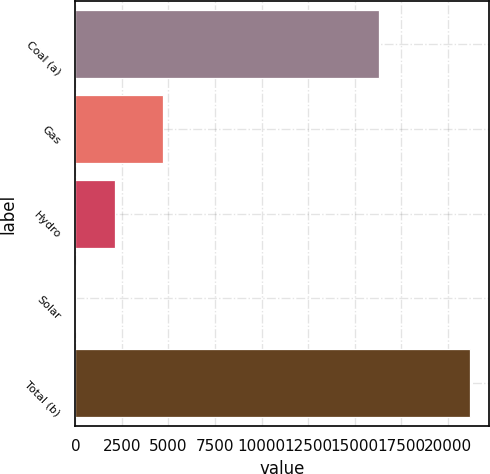Convert chart. <chart><loc_0><loc_0><loc_500><loc_500><bar_chart><fcel>Coal (a)<fcel>Gas<fcel>Hydro<fcel>Solar<fcel>Total (b)<nl><fcel>16296<fcel>4717<fcel>2126.6<fcel>10<fcel>21176<nl></chart> 